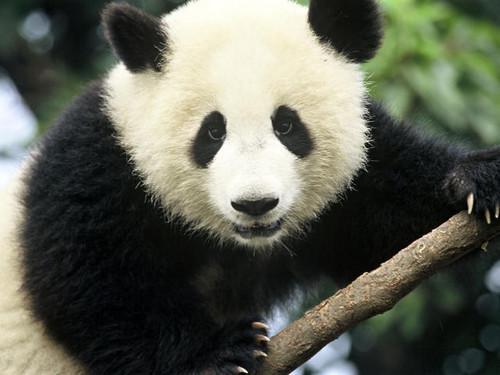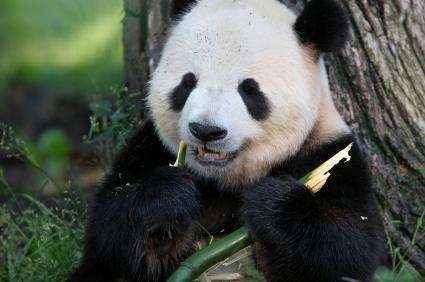The first image is the image on the left, the second image is the image on the right. For the images displayed, is the sentence "In one of the images, a panda has food in its mouth" factually correct? Answer yes or no. Yes. The first image is the image on the left, the second image is the image on the right. Evaluate the accuracy of this statement regarding the images: "In one of the images, a panda is eating something". Is it true? Answer yes or no. Yes. The first image is the image on the left, the second image is the image on the right. Assess this claim about the two images: "A panda is eating in one of the images.". Correct or not? Answer yes or no. Yes. 